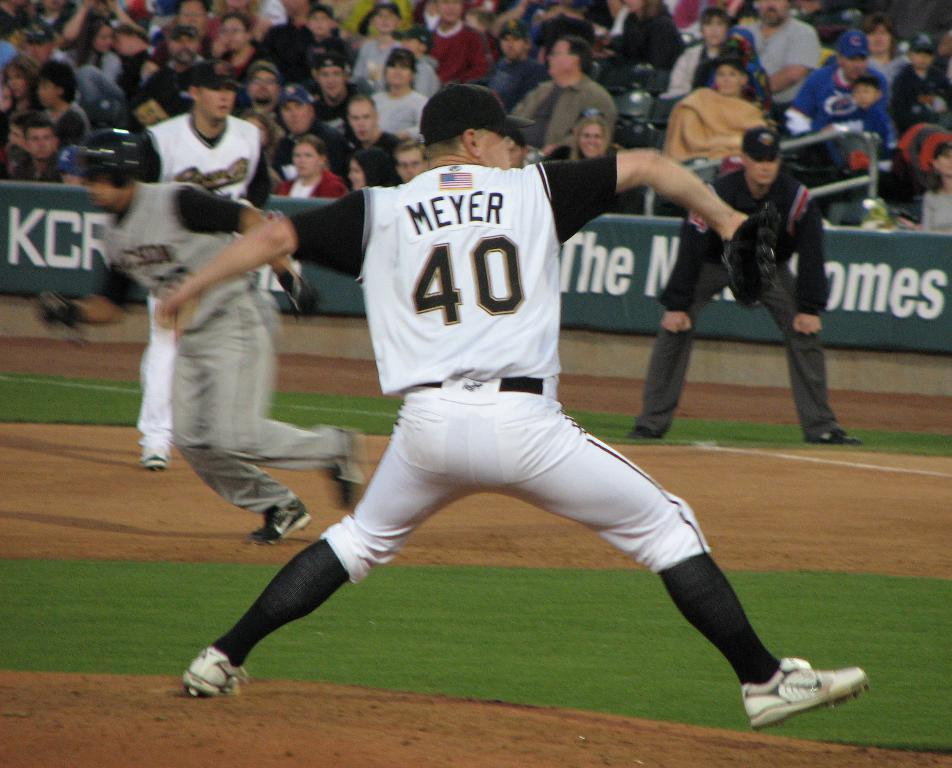<image>
Offer a succinct explanation of the picture presented. a player that has the number 40 on their jersey 